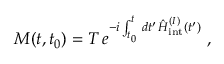<formula> <loc_0><loc_0><loc_500><loc_500>M ( t , t _ { 0 } ) = T \, e ^ { - i \int _ { t _ { 0 } } ^ { t } \, d t ^ { \prime } \, \hat { H } _ { i n t } ^ { ( I ) } ( t ^ { \prime } ) } \ ,</formula> 